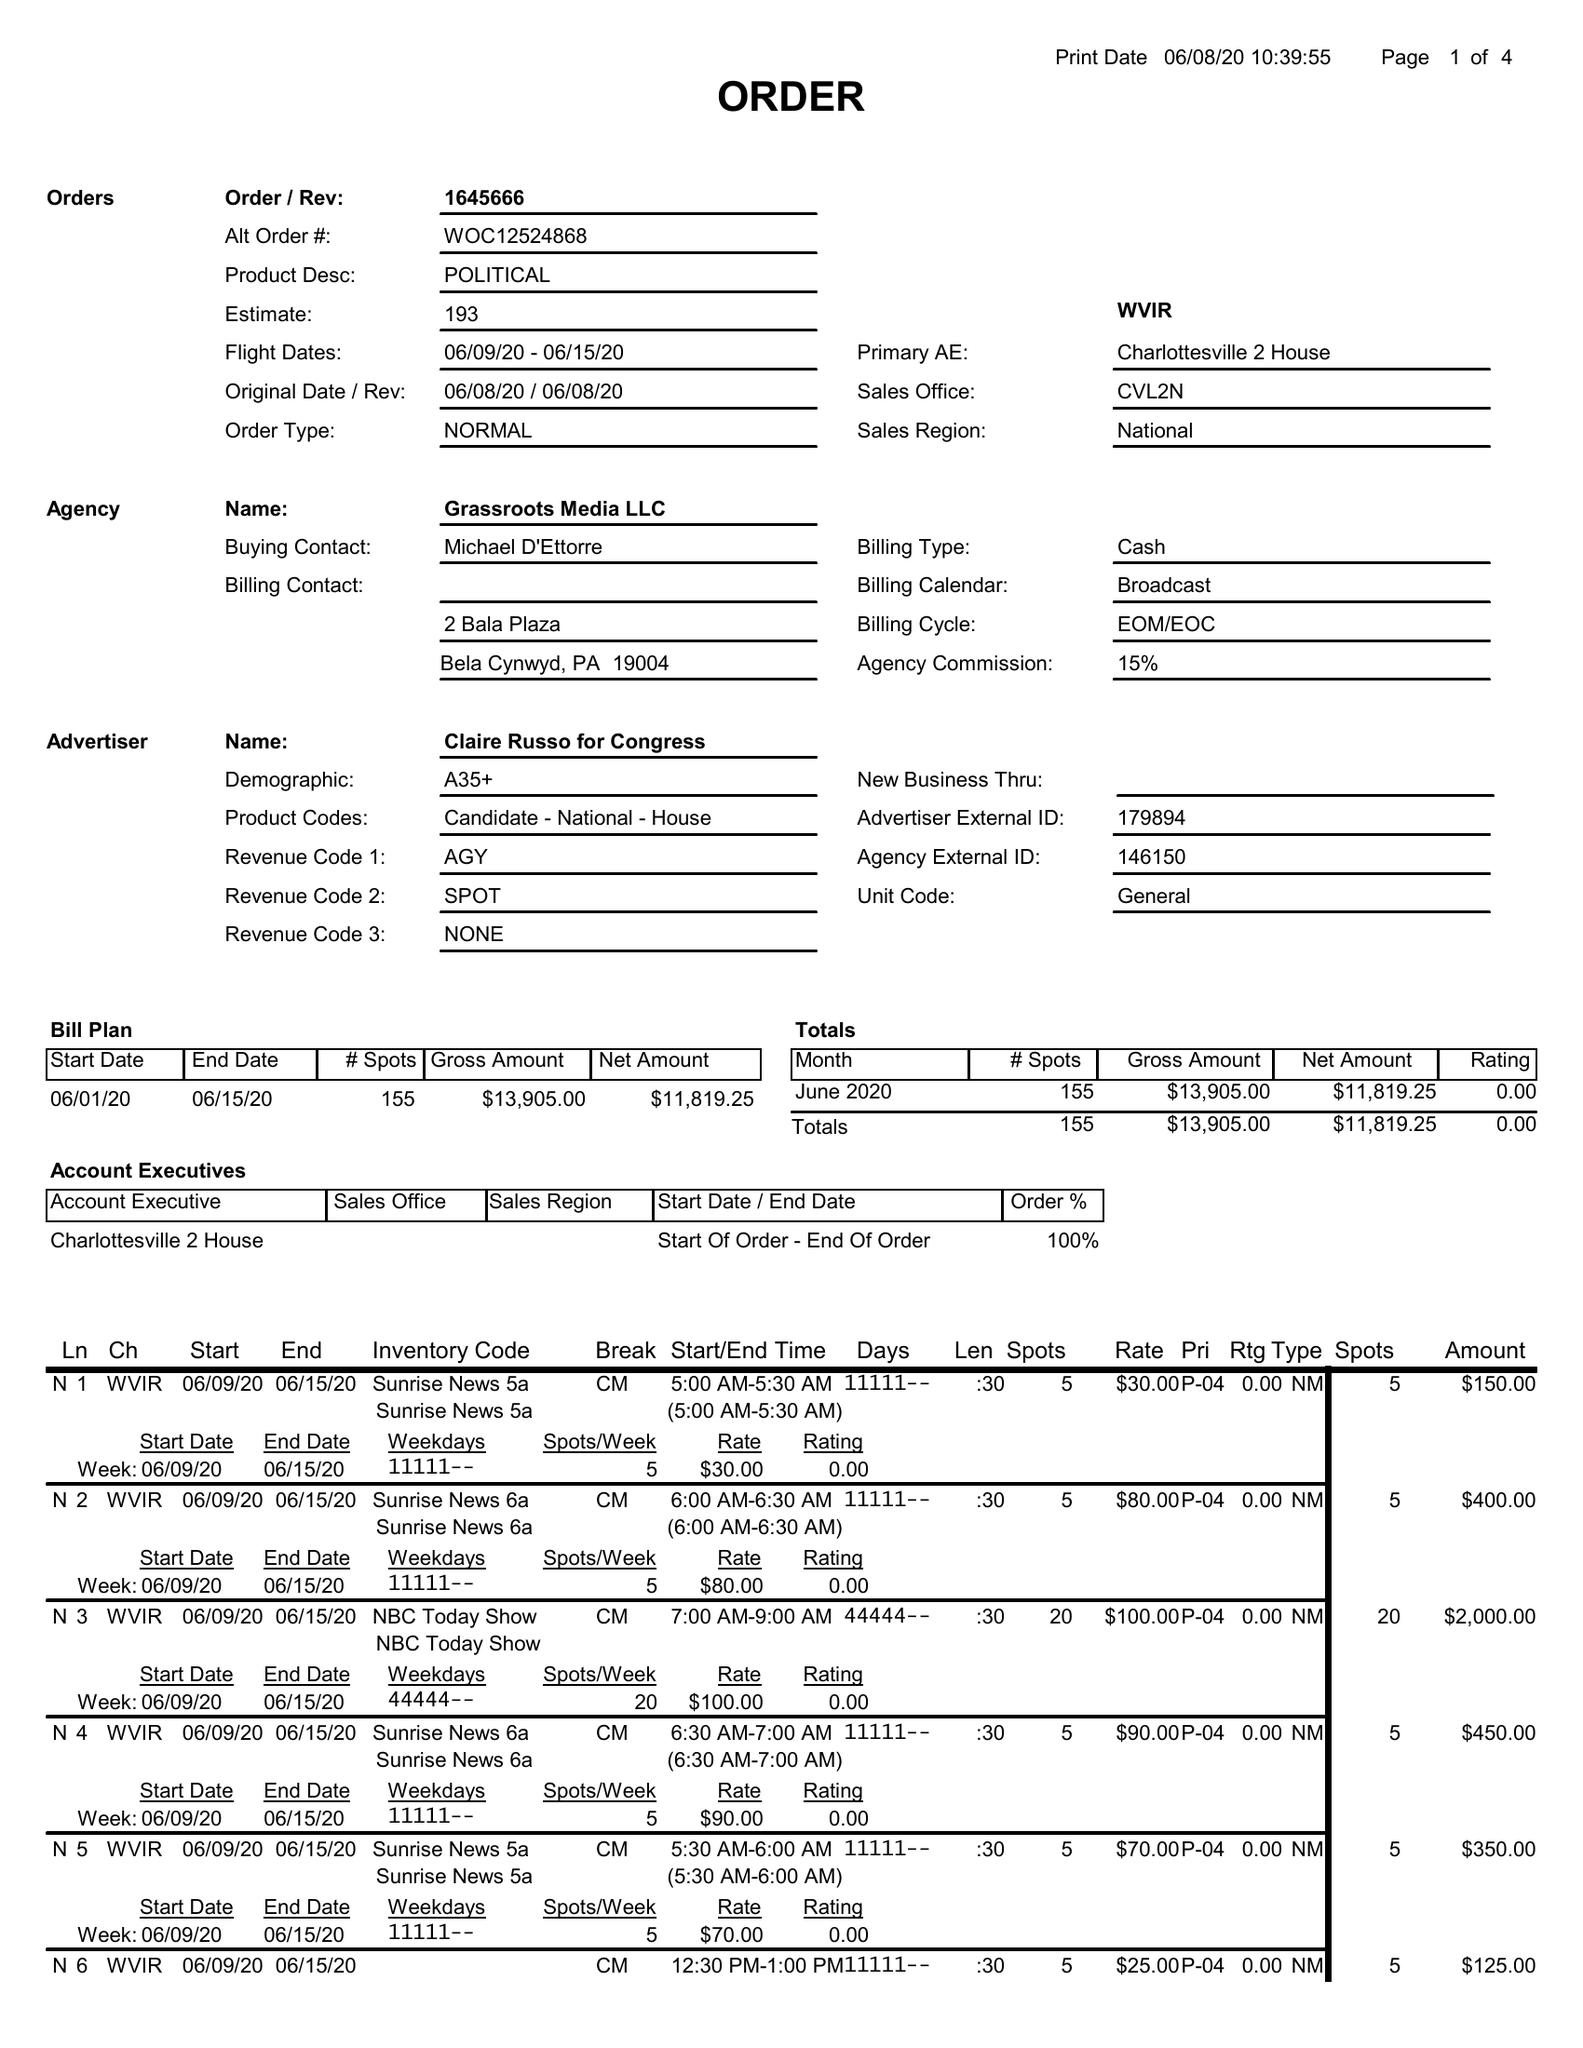What is the value for the flight_from?
Answer the question using a single word or phrase. 06/09/20 